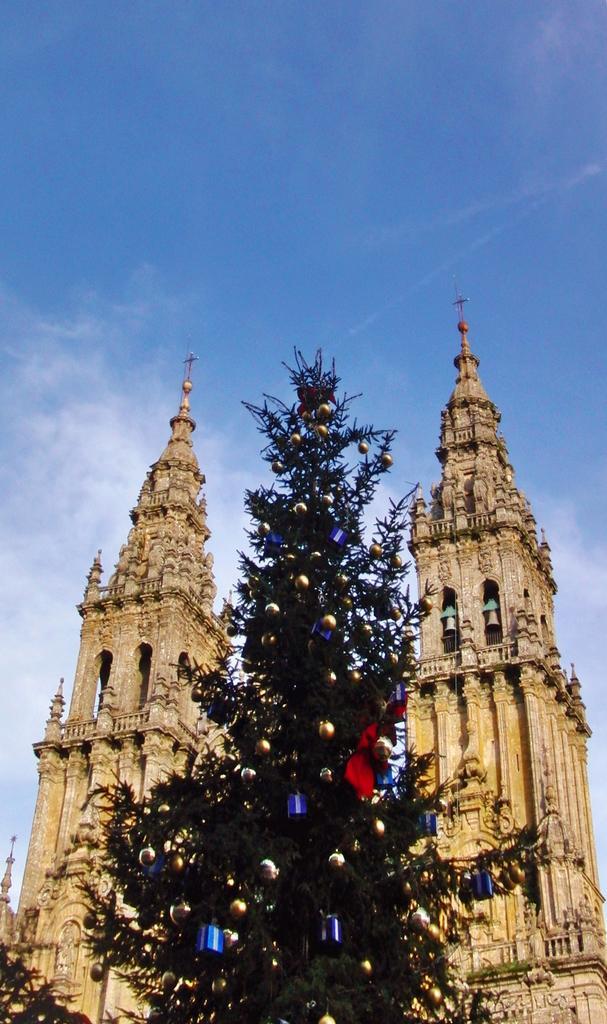Can you describe this image briefly? In this image there is a Christmas tree, in the background there are churches and the sky. 